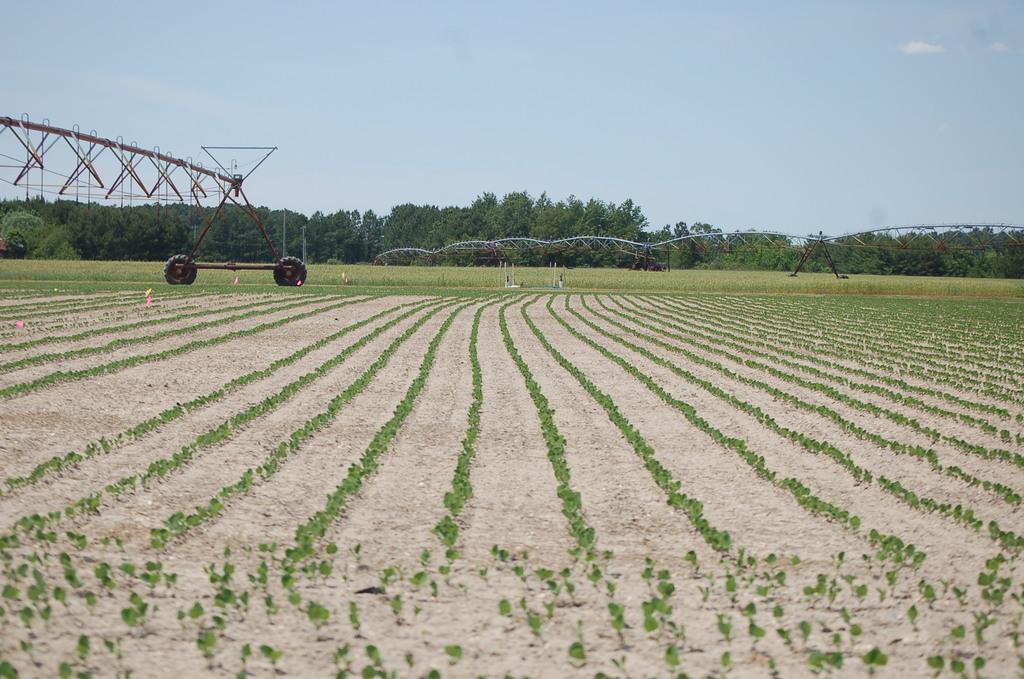Can you describe this image briefly? In this image there are crops. Behind the crops there are metal rod structures with tires. In the background of the image there are trees. At the top of the image there is sky. 